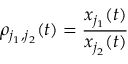Convert formula to latex. <formula><loc_0><loc_0><loc_500><loc_500>\rho _ { j _ { 1 } , j _ { 2 } } ( t ) = \frac { x _ { j _ { 1 } } ( t ) } { x _ { j _ { 2 } } ( t ) }</formula> 